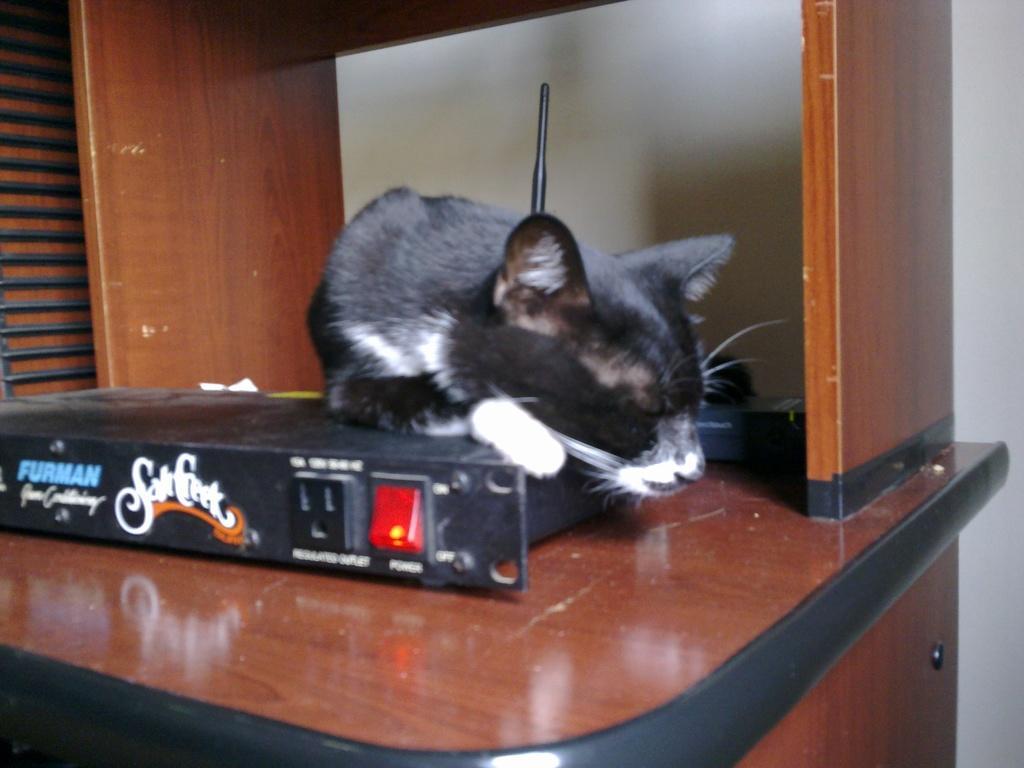Please provide a concise description of this image. This image consists of a box. On that there is a rat. It is in black color. This looks like an antenna box. 